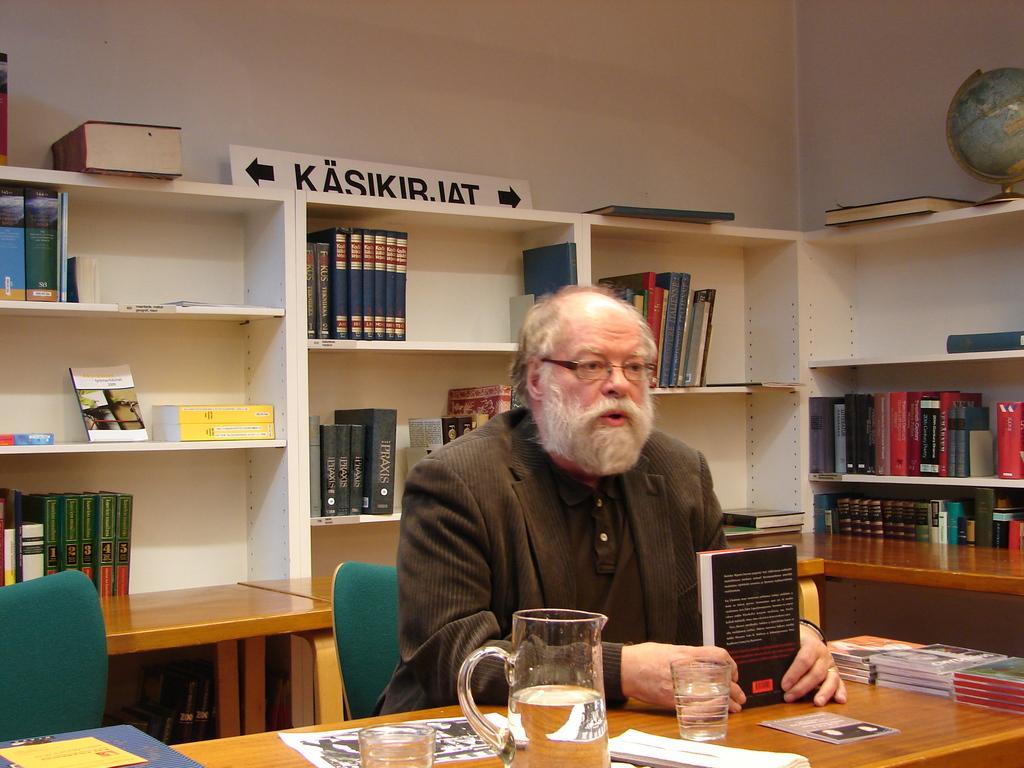Describe this image in one or two sentences. In this picture we can see a man sitting on a chair in front of a table, there are some books, two glasses, a jar present on the table, in the background there are some shelves, we can see some files and books on the shelves, there is a globe here, in the background there is a wall, we can see a board here. 